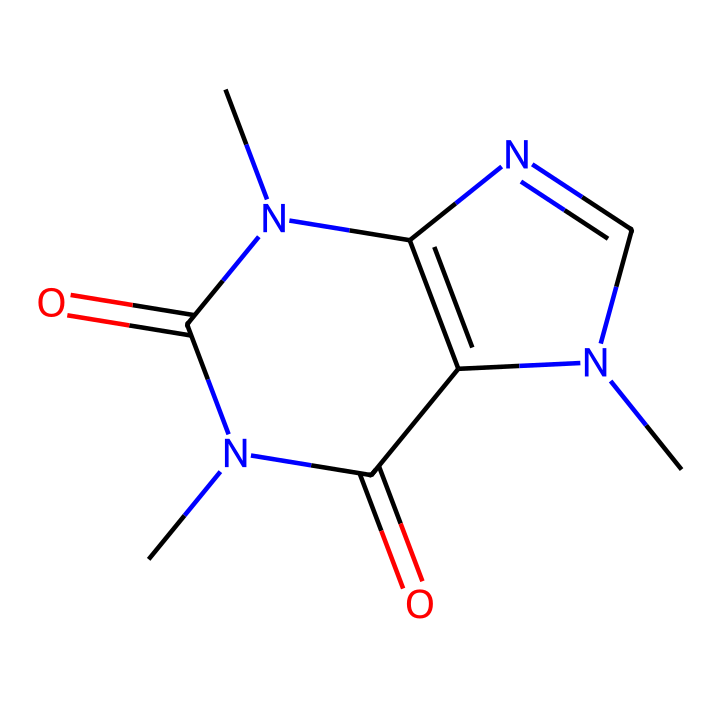What is the molecular formula of this substance? To determine the molecular formula from the SMILES, we can analyze the elements represented. The structure consists of carbon (C), nitrogen (N), and oxygen (O) atoms. Counting the atoms in the SMILES yields 8 carbon atoms, 10 hydrogen atoms, 4 nitrogen atoms, and 2 oxygen atoms. Thus, the molecular formula is C8H10N4O2.
Answer: C8H10N4O2 How many rings are present in the structure? From the SMILES notation, we look for numbers indicating the start and end of rings. The presence of '1' and '2' suggests there are two cyclic structures or rings in the molecule. Therefore, the total number of rings is 2.
Answer: 2 What property leads caffeine to be classified as a stimulant? The presence of nitrogen atoms in a heterocyclic structure is a critical factor in caffeine's classification. These nitrogen atoms contribute to its pharmacological effects by interacting with adenosine receptors in the brain, promoting wakefulness.
Answer: nitrogen What type of compound is caffeine classified as? Analyzing its structure, caffeine has a nitrogen-containing ring structure typical of alkaloids, which are naturally occurring organic compounds. Alkaloids are known for their physiological effects on humans and other animals. Hence, caffeine is classified as an alkaloid.
Answer: alkaloid How many nitrogen atoms are in the structure? By examining the SMILES representation, we can count the occurrences of the letter 'N' which indicates nitrogen atoms. In this structure, there are four instances of 'N', leading us to conclude there are four nitrogen atoms.
Answer: 4 Which parts of the structure contribute to its solubility in water? The polar functional groups, in particular the nitrogen atoms and the carbonyl (C=O) groups, contribute to the molecular polarity and enhance solubility in water. This property is essential for its absorption in the digestive tract.
Answer: nitrogen, carbonyl What does the presence of the carbonyl groups imply about caffeine? The carbonyl groups (C=O) present in the structure indicate that caffeine can form hydrogen bonds with water molecules, enhancing its interaction with aqueous environments. This contributes to its solubility and pharmacokinetics in the body.
Answer: hydrogen bonds 